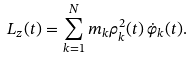<formula> <loc_0><loc_0><loc_500><loc_500>L _ { z } ( t ) = \sum _ { k = 1 } ^ { N } m _ { k } \rho _ { k } ^ { 2 } ( t ) \, \dot { \varphi } _ { k } ( t ) .</formula> 